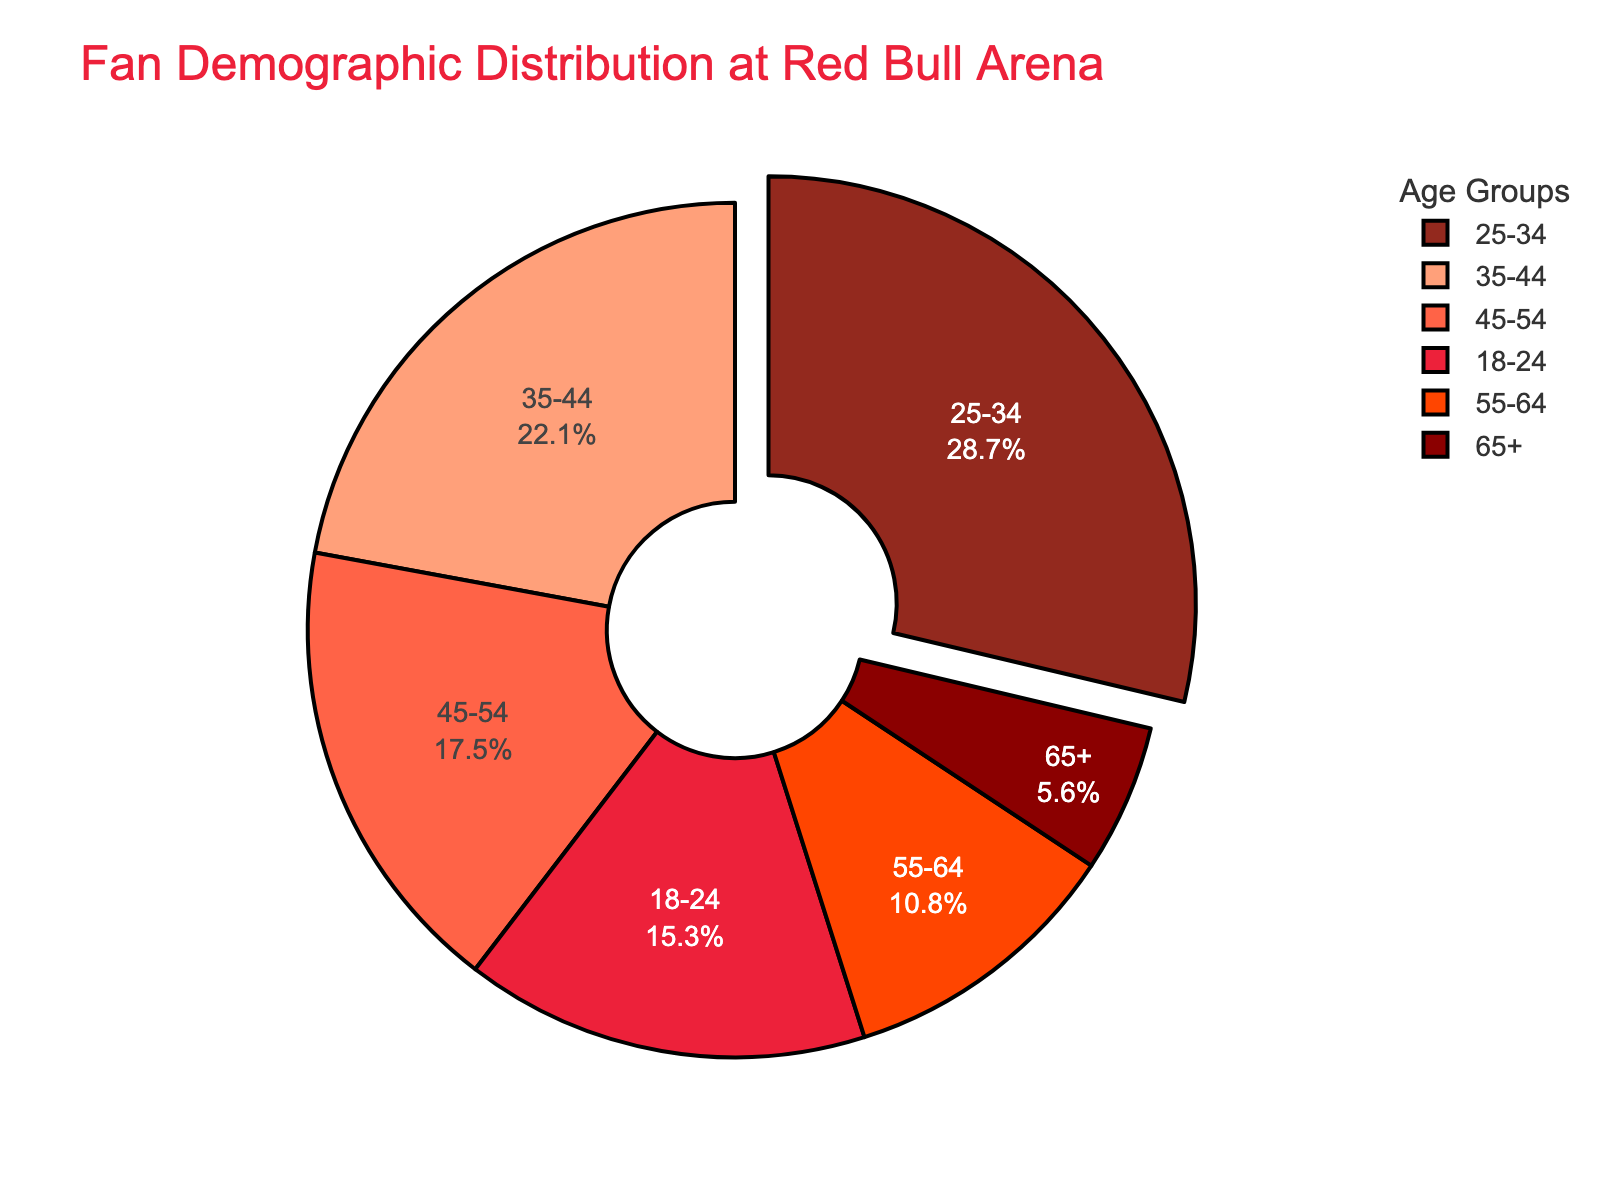What's the most represented age group of fans? The plot highlights the 25-34 age group by pulling it out from the pie chart and showing they have the highest percentage. The text on the chart indicates they make up 28.7% of the fans.
Answer: 25-34 What's the combined percentage of fans aged between 18-34? To find the combined percentage for the age groups 18-24 and 25-34, we sum their percentages: 15.3 + 28.7 = 44.0.
Answer: 44.0% Which age group has the smallest representation among fans? By examining the pie chart, the smallest segment corresponds to the 65+ age group, representing 5.6% of the fans.
Answer: 65+ What's the percentage difference between the 25-34 and 55-64 age groups? Subtract the percentage of the 55-64 age group from the 25-34 age group: 28.7 - 10.8 = 17.9.
Answer: 17.9% What percentage of fans are aged 35 and above? Sum the percentages for the 35-44, 45-54, 55-64, and 65+ age groups: 22.1 + 17.5 + 10.8 + 5.6 = 56.0.
Answer: 56.0% Between which two consecutive age groups is the largest percentage gap? Calculate the differences between consecutive age groups: 25-34 (28.7%) - 18-24 (15.3%) = 13.4, 35-44 (22.1%) - 25-34 (28.7%) = -6.6, 45-54 (17.5%) - 35-44 (22.1%) = -4.6, 55-64 (10.8%) - 45-54 (17.5%) = -6.7, 65+ (5.6%) - 55-64 (10.8%) = -5.2. The largest gap is between 18-24 and 25-34 with a difference of 13.4%.
Answer: 18-24 and 25-34 How much larger is the 25-34 age group's percentage compared to the 45-54 group? Subtract the percentage of the 45-54 age group from the 25-34 age group: 28.7 - 17.5 = 11.2.
Answer: 11.2% What is the average percentage of fans in the 35-44 and 45-54 age groups? The average percentage is calculated by summing the percentages of the 35-44 and 45-54 groups and then dividing by 2: (22.1 + 17.5) / 2 = 19.8.
Answer: 19.8% Which two age groups have the most similar percentages? Compare the differences: 18-24 (15.3%) and 55-64 (10.8%) = 4.5, 25-34 (28.7%) and 45-54 (17.5%) = 11.2, 35-44 (22.1%) and 65+ (5.6%) = 16.5. The closest percentages are 18-24 and 55-64 with a difference of 4.5%.
Answer: 18-24 and 55-64 What color represents the 65+ age group? Visually inspecting the pie chart, the color representing the 65+ age group is the darkest red shade.
Answer: darkest red 